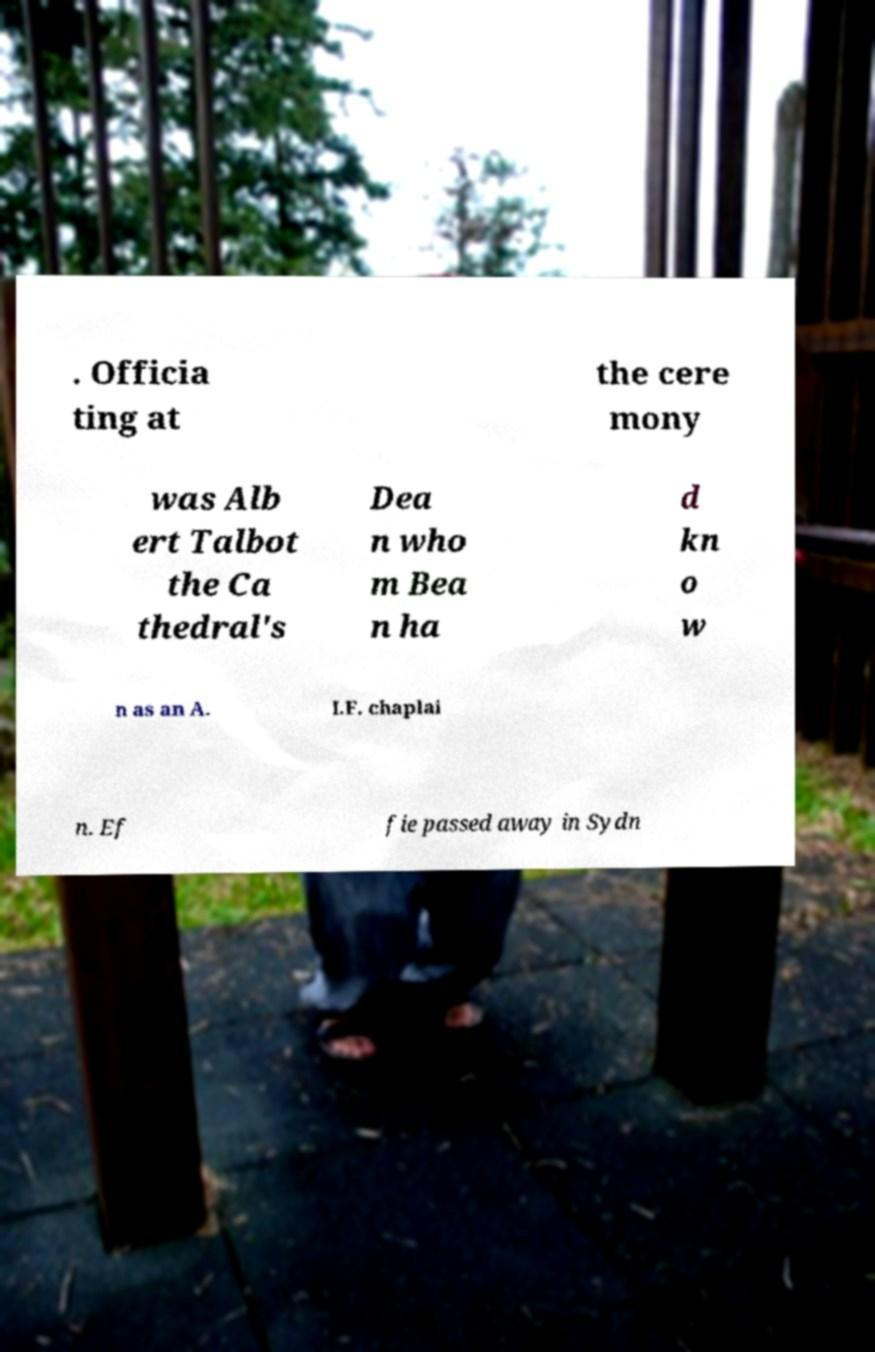Could you assist in decoding the text presented in this image and type it out clearly? . Officia ting at the cere mony was Alb ert Talbot the Ca thedral's Dea n who m Bea n ha d kn o w n as an A. I.F. chaplai n. Ef fie passed away in Sydn 